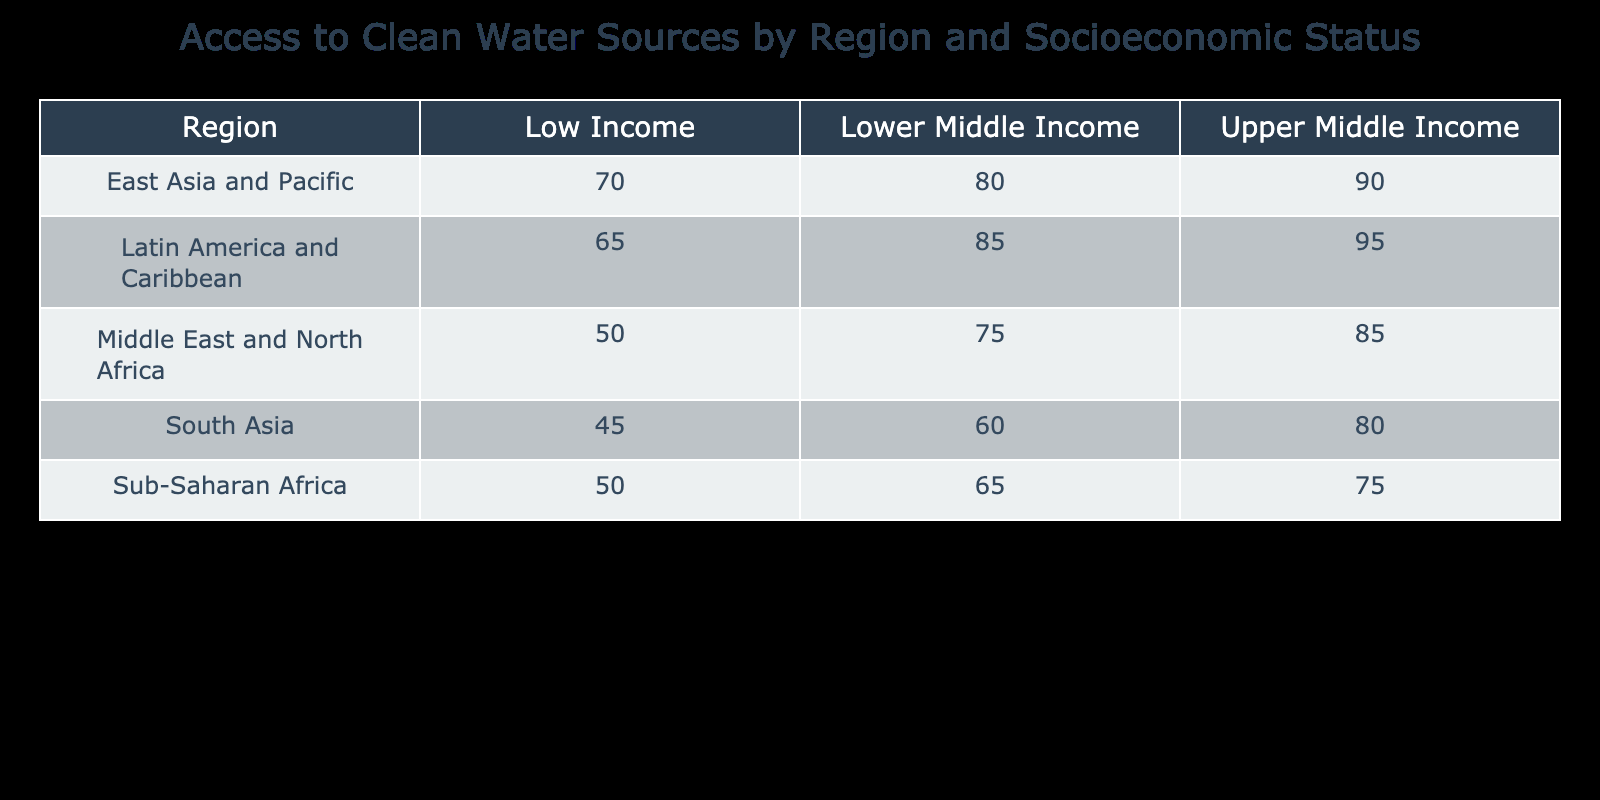What percentage of Upper Middle Income individuals in East Asia and Pacific have access to clean water? The table shows that for the Upper Middle Income group in East Asia and Pacific, the percentage of access to clean water is explicitly listed as 90.
Answer: 90 What is the difference in access to clean water between Low Income groups in Sub-Saharan Africa and South Asia? From the table, Sub-Saharan Africa has 50% access while South Asia has 45%. The difference is calculated as 50% - 45% = 5%.
Answer: 5% Is the access to clean water for Lower Middle Income individuals in Latin America and Caribbean higher than that of the Upper Middle Income in Sub-Saharan Africa? The access percentage for Lower Middle Income in Latin America and Caribbean is 85%, while for Upper Middle Income in Sub-Saharan Africa, it is 75%. Since 85% is greater than 75%, the statement is true.
Answer: Yes What is the average percentage of access to clean water for Upper Middle Income populations across all regions? The access percentages for Upper Middle Income populations are 75 (Sub-Saharan Africa), 80 (South Asia), 90 (East Asia and Pacific), 95 (Latin America and Caribbean), and 85 (Middle East and North Africa). The total sum is 75 + 80 + 90 + 95 + 85 = 425. There are 5 regions, so the average is 425 / 5 = 85.
Answer: 85 Is it true that all regions have a higher percentage of access to clean water in Upper Middle Income than in Low Income? Reviewing the table, all regions show higher access percentages for Upper Middle Income than for Low Income: Sub-Saharan Africa (75 vs 50), South Asia (80 vs 45), East Asia and Pacific (90 vs 70), Latin America and Caribbean (95 vs 65), and Middle East and North Africa (85 vs 50). Thus, the statement is true.
Answer: Yes What is the highest percentage of access to clean water reported in the Low Income category and which region does it come from? The highest value in the Low Income category is 70, which is found in East Asia and Pacific.
Answer: 70 (East Asia and Pacific) How many regions have an access percentage of at least 80 for the Upper Middle Income group? The Upper Middle Income percentages are 75 (Sub-Saharan Africa), 80 (South Asia), 90 (East Asia and Pacific), 95 (Latin America and Caribbean), and 85 (Middle East and North Africa). The regions with at least 80 are South Asia, East Asia and Pacific, Latin America and Caribbean, and Middle East and North Africa. There are 4 regions meeting this criteria.
Answer: 4 What percentage of Lower Middle Income individuals in Sub-Saharan Africa have access to clean water, and how does it compare with the Lower Middle Income in East Asia and Pacific? The table shows that Lower Middle Income in Sub-Saharan Africa has 65% access, while in East Asia and Pacific it is 80%. Since 65% is less than 80%, this comparison indicates that East Asia and Pacific has a higher percentage.
Answer: 65 (less than 80) 